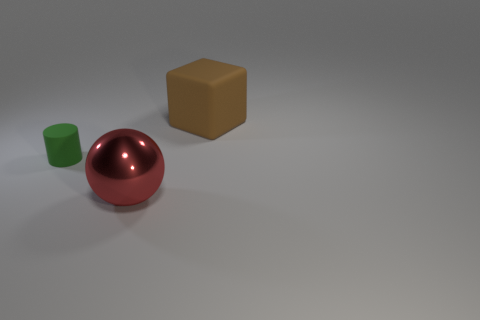Are there any other objects in the image besides the red ball, green cylinder, and brown cube? No, the image only contains the three objects you've mentioned—a red ball, a green cylinder, and a brown cube—set against a neutral gray background with no other distinguishable items. 